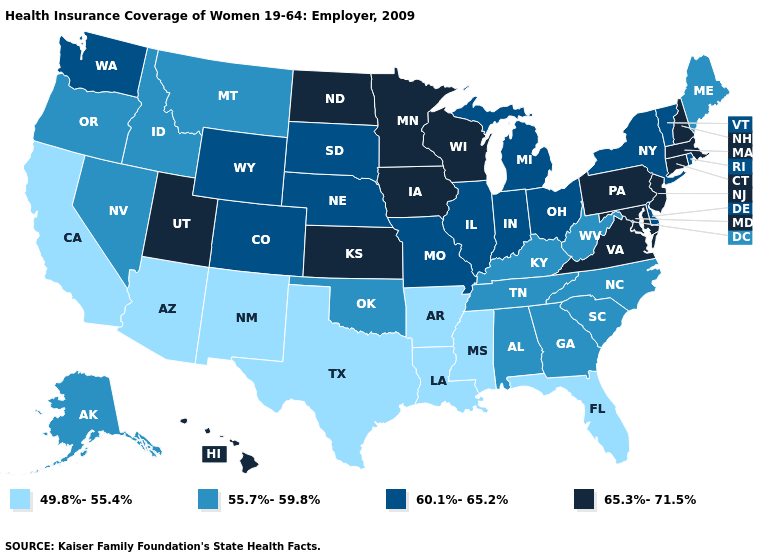Name the states that have a value in the range 65.3%-71.5%?
Give a very brief answer. Connecticut, Hawaii, Iowa, Kansas, Maryland, Massachusetts, Minnesota, New Hampshire, New Jersey, North Dakota, Pennsylvania, Utah, Virginia, Wisconsin. What is the value of Missouri?
Quick response, please. 60.1%-65.2%. Which states hav the highest value in the South?
Write a very short answer. Maryland, Virginia. What is the value of California?
Be succinct. 49.8%-55.4%. Name the states that have a value in the range 55.7%-59.8%?
Answer briefly. Alabama, Alaska, Georgia, Idaho, Kentucky, Maine, Montana, Nevada, North Carolina, Oklahoma, Oregon, South Carolina, Tennessee, West Virginia. What is the value of Maryland?
Answer briefly. 65.3%-71.5%. Among the states that border Ohio , which have the lowest value?
Concise answer only. Kentucky, West Virginia. Which states hav the highest value in the West?
Give a very brief answer. Hawaii, Utah. What is the value of Kansas?
Write a very short answer. 65.3%-71.5%. What is the value of Minnesota?
Give a very brief answer. 65.3%-71.5%. What is the value of Ohio?
Quick response, please. 60.1%-65.2%. Name the states that have a value in the range 65.3%-71.5%?
Concise answer only. Connecticut, Hawaii, Iowa, Kansas, Maryland, Massachusetts, Minnesota, New Hampshire, New Jersey, North Dakota, Pennsylvania, Utah, Virginia, Wisconsin. What is the value of New Mexico?
Give a very brief answer. 49.8%-55.4%. Name the states that have a value in the range 60.1%-65.2%?
Concise answer only. Colorado, Delaware, Illinois, Indiana, Michigan, Missouri, Nebraska, New York, Ohio, Rhode Island, South Dakota, Vermont, Washington, Wyoming. What is the value of Mississippi?
Write a very short answer. 49.8%-55.4%. 